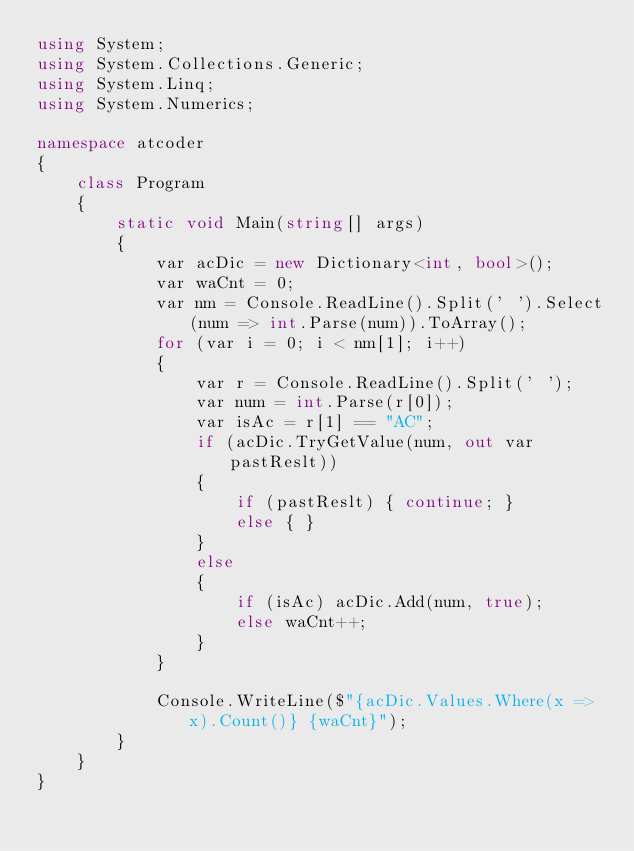<code> <loc_0><loc_0><loc_500><loc_500><_C#_>using System;
using System.Collections.Generic;
using System.Linq;
using System.Numerics;

namespace atcoder
{
    class Program
    {
        static void Main(string[] args)
        {
            var acDic = new Dictionary<int, bool>();
            var waCnt = 0;
            var nm = Console.ReadLine().Split(' ').Select(num => int.Parse(num)).ToArray();
            for (var i = 0; i < nm[1]; i++)
            {
                var r = Console.ReadLine().Split(' ');
                var num = int.Parse(r[0]);
                var isAc = r[1] == "AC";
                if (acDic.TryGetValue(num, out var pastReslt))
                {
                    if (pastReslt) { continue; }
                    else { }
                }
                else
                {
                    if (isAc) acDic.Add(num, true);
                    else waCnt++;
                }
            }

            Console.WriteLine($"{acDic.Values.Where(x => x).Count()} {waCnt}");
        }
    }
}</code> 